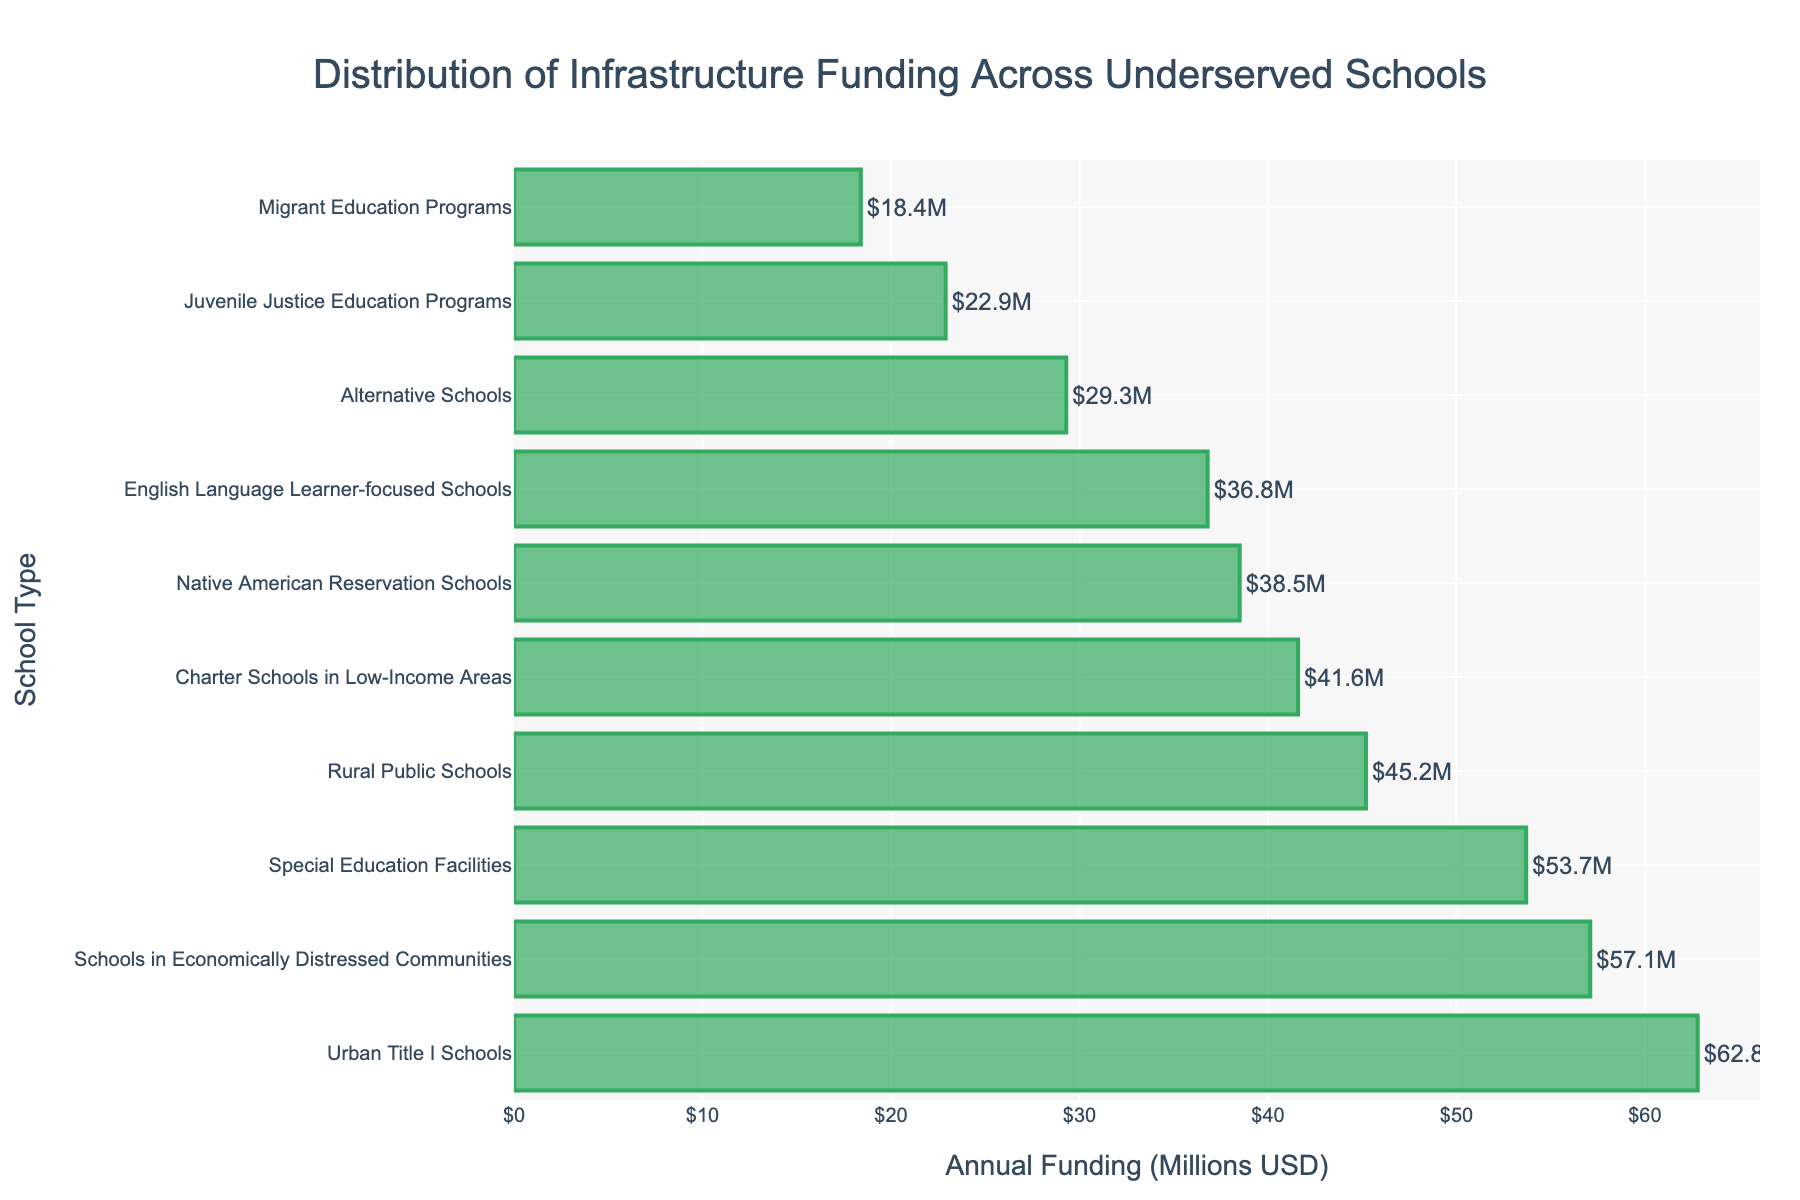Which type of school receives the highest amount of funding? By looking at the lengths of the bars, we can identify the school type with the longest bar, which represents the highest funding.
Answer: Urban Title I Schools Which type of school receives the least amount of funding? By examining the lengths of the bars, we can see that the shortest bar represents the school type with the least funding.
Answer: Migrant Education Programs What is the total funding for Rural Public Schools and Special Education Facilities? Sum the funding amounts for these two school types: 45.2 + 53.7 = 98.9
Answer: 98.9 million USD How much more funding do Urban Title I Schools receive compared to Charter Schools in Low-Income Areas? Subtract the funding for Charter Schools from Urban Title I Schools: 62.8 - 41.6 = 21.2
Answer: 21.2 million USD Are there any school types whose funding differences are less than 10 million USD apart? Compare the funding amounts and identify pairs with differences less than 10 million USD: Rural Public Schools (45.2) and Charter Schools (41.6) have a difference of 3.6 million USD.
Answer: Yes What is the average funding provided to the school types in the chart? Sum the funding amounts and divide by the number of school types: (45.2 + 62.8 + 38.5 + 53.7 + 29.3 + 41.6 + 22.9 + 18.4 + 57.1 + 36.8) / 10 = 40.63
Answer: 40.63 million USD Which type of school receives more funding: Special Education Facilities or Schools in Economically Distressed Communities? By comparing the lengths of the bars, Schools in Economically Distressed Communities receive more funding.
Answer: Schools in Economically Distressed Communities What is the combined funding for English Language Learner-focused Schools, Native American Reservation Schools, and Alternative Schools? Sum the funding for these three school types: 36.8 + 38.5 + 29.3 = 104.6
Answer: 104.6 million USD Which two types of schools are closest in funding? By comparing the lengths of the bars, Rural Public Schools (45.2) and Charter Schools (41.6) have the closest funding amounts.
Answer: Rural Public Schools and Charter Schools in Low-Income Areas 